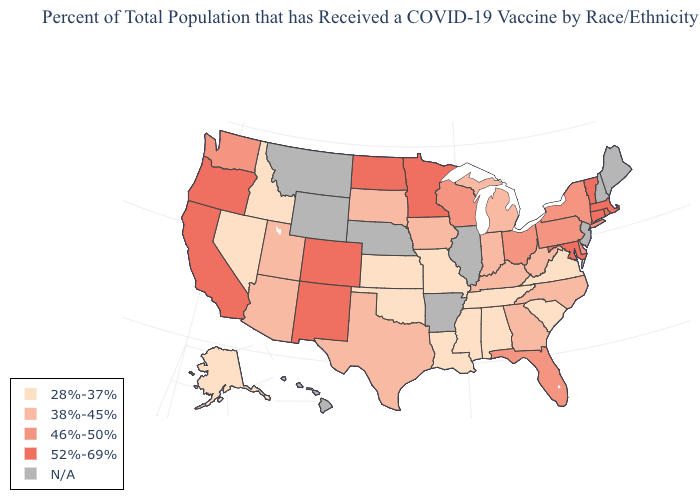Among the states that border Connecticut , does Massachusetts have the highest value?
Give a very brief answer. Yes. Name the states that have a value in the range 46%-50%?
Answer briefly. Delaware, Florida, New York, Ohio, Pennsylvania, Washington, Wisconsin. Does the map have missing data?
Quick response, please. Yes. Does the first symbol in the legend represent the smallest category?
Write a very short answer. Yes. Does Maryland have the highest value in the South?
Quick response, please. Yes. Which states have the lowest value in the Northeast?
Be succinct. New York, Pennsylvania. What is the lowest value in states that border Illinois?
Be succinct. 28%-37%. Among the states that border Wyoming , which have the lowest value?
Quick response, please. Idaho. What is the value of West Virginia?
Answer briefly. 38%-45%. Which states have the lowest value in the South?
Quick response, please. Alabama, Louisiana, Mississippi, Oklahoma, South Carolina, Tennessee, Virginia. Does New York have the lowest value in the USA?
Answer briefly. No. Does Delaware have the highest value in the USA?
Short answer required. No. Which states have the highest value in the USA?
Short answer required. California, Colorado, Connecticut, Maryland, Massachusetts, Minnesota, New Mexico, North Dakota, Oregon, Rhode Island, Vermont. Does the map have missing data?
Short answer required. Yes. Which states have the lowest value in the USA?
Be succinct. Alabama, Alaska, Idaho, Kansas, Louisiana, Mississippi, Missouri, Nevada, Oklahoma, South Carolina, Tennessee, Virginia. 